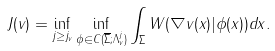<formula> <loc_0><loc_0><loc_500><loc_500>\ J ( v ) = \inf _ { j \geq j _ { v } } \inf _ { \phi \in C ( \overline { \Sigma } ; \Lambda _ { v } ^ { j } ) } \int _ { \Sigma } W ( \nabla v ( x ) | \phi ( x ) ) d x .</formula> 